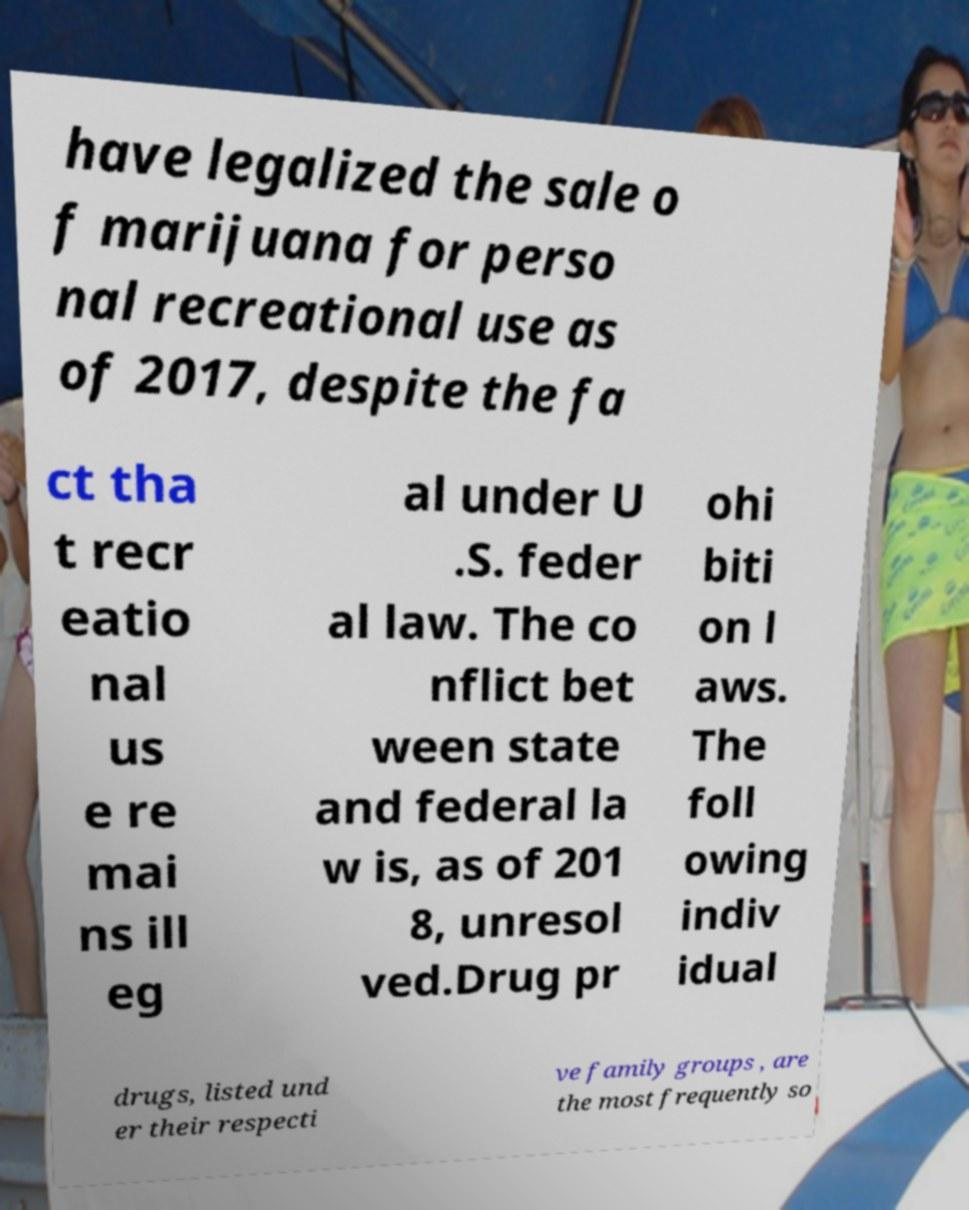Can you accurately transcribe the text from the provided image for me? have legalized the sale o f marijuana for perso nal recreational use as of 2017, despite the fa ct tha t recr eatio nal us e re mai ns ill eg al under U .S. feder al law. The co nflict bet ween state and federal la w is, as of 201 8, unresol ved.Drug pr ohi biti on l aws. The foll owing indiv idual drugs, listed und er their respecti ve family groups , are the most frequently so 